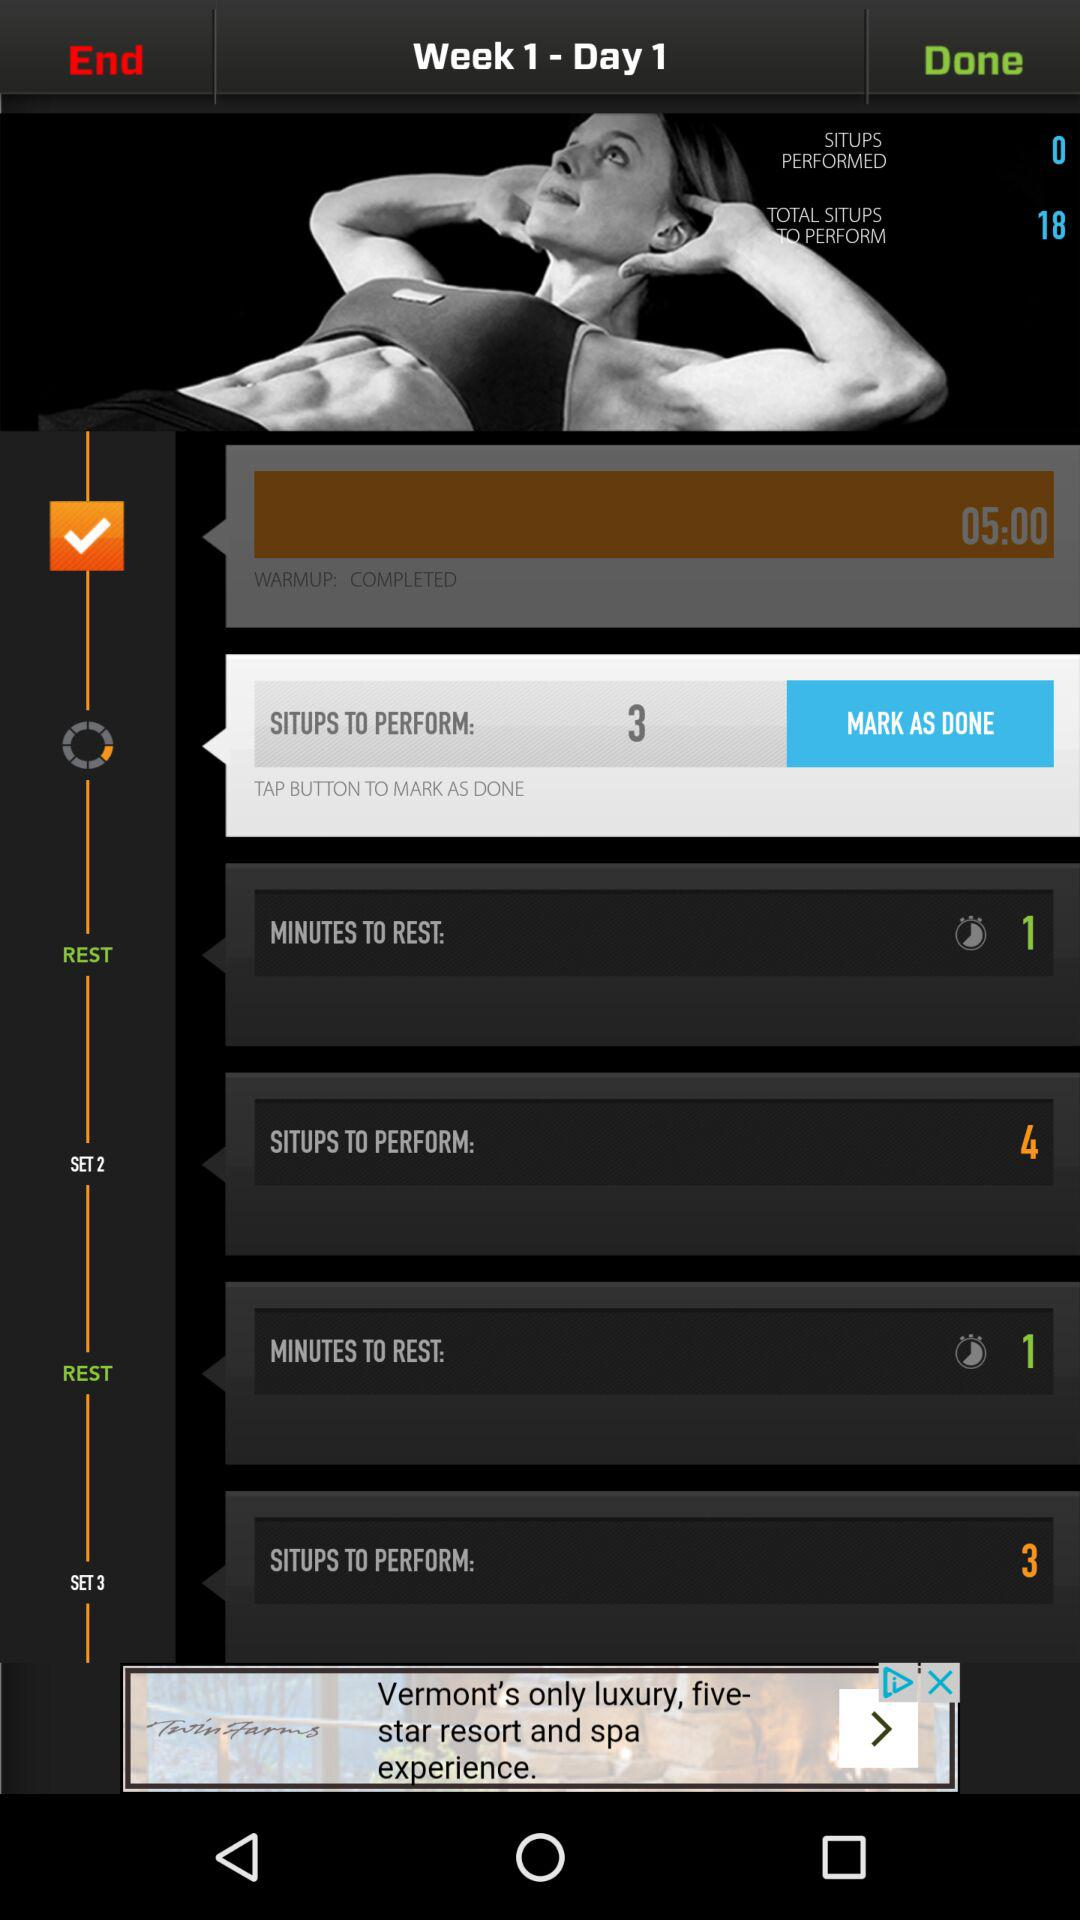What is the time duration for warmup? The time duration for warmup is 5 minutes. 